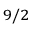Convert formula to latex. <formula><loc_0><loc_0><loc_500><loc_500>_ { 9 / 2 }</formula> 